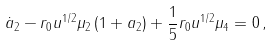<formula> <loc_0><loc_0><loc_500><loc_500>\dot { a } _ { 2 } - r _ { 0 } u ^ { 1 / 2 } \mu _ { 2 } \left ( 1 + a _ { 2 } \right ) + \frac { 1 } { 5 } r _ { 0 } u ^ { 1 / 2 } \mu _ { 4 } = 0 \, ,</formula> 